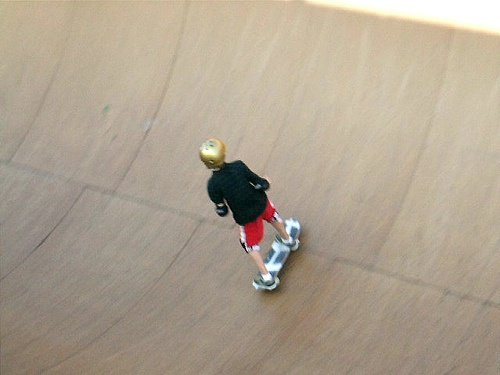Describe the objects in this image and their specific colors. I can see people in tan, black, darkgray, brown, and gray tones and skateboard in tan, lightblue, gray, and darkgray tones in this image. 